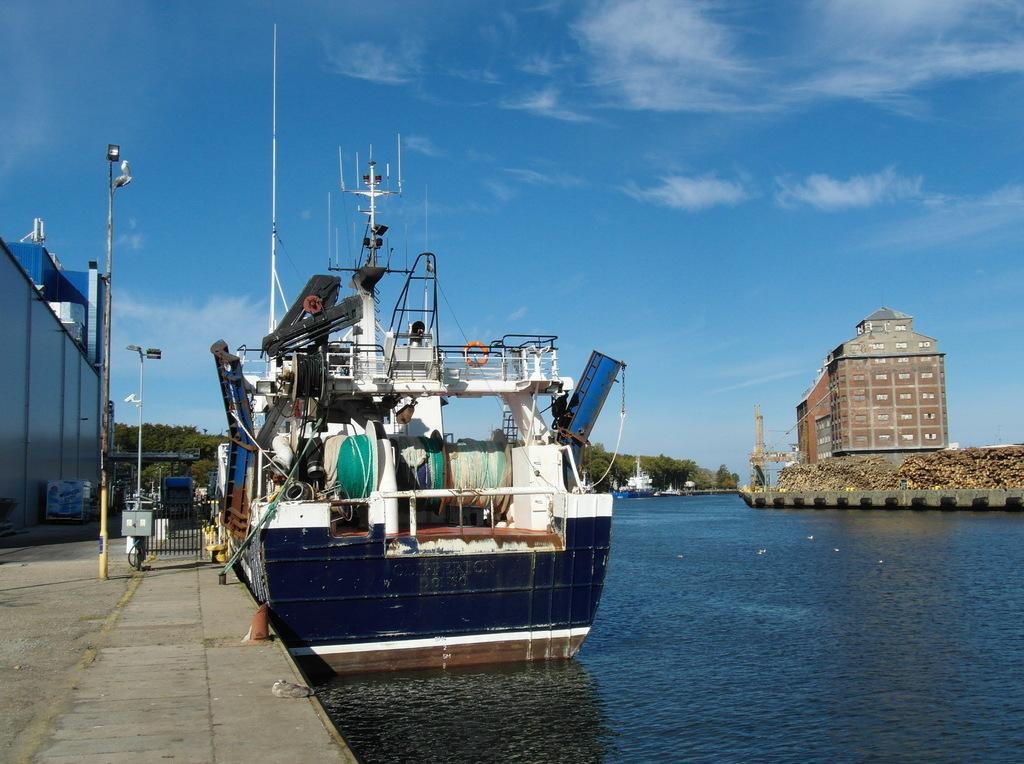Please provide a concise description of this image. This image consists of a ship in blue color. At the bottom, there is water. To the left, there is a building along with a pole. At the top, there are clouds in the sky. 